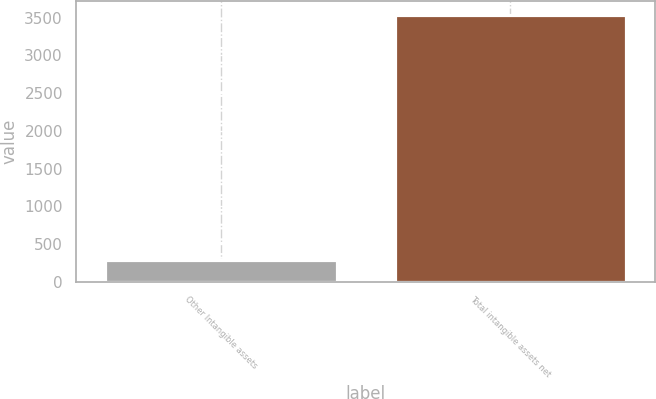Convert chart to OTSL. <chart><loc_0><loc_0><loc_500><loc_500><bar_chart><fcel>Other Intangible assets<fcel>Total intangible assets net<nl><fcel>291<fcel>3541<nl></chart> 